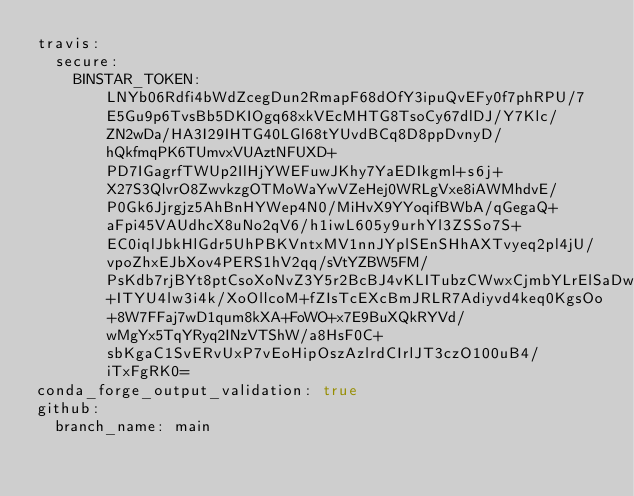<code> <loc_0><loc_0><loc_500><loc_500><_YAML_>travis:
  secure:
    BINSTAR_TOKEN: LNYb06Rdfi4bWdZcegDun2RmapF68dOfY3ipuQvEFy0f7phRPU/7E5Gu9p6TvsBb5DKIOgq68xkVEcMHTG8TsoCy67dlDJ/Y7Klc/ZN2wDa/HA3I29IHTG40LGl68tYUvdBCq8D8ppDvnyD/hQkfmqPK6TUmvxVUAztNFUXD+PD7IGagrfTWUp2IlHjYWEFuwJKhy7YaEDIkgml+s6j+X27S3QlvrO8ZwvkzgOTMoWaYwVZeHej0WRLgVxe8iAWMhdvE/P0Gk6Jjrgjz5AhBnHYWep4N0/MiHvX9YYoqifBWbA/qGegaQ+aFpi45VAUdhcX8uNo2qV6/h1iwL605y9urhYl3ZSSo7S+EC0iqlJbkHlGdr5UhPBKVntxMV1nnJYplSEnSHhAXTvyeq2pl4jU/vpoZhxEJbXov4PERS1hV2qq/sVtYZBW5FM/PsKdb7rjBYt8ptCsoXoNvZ3Y5r2BcBJ4vKLITubzCWwxCjmbYLrElSaDwvo392+ITYU4lw3i4k/XoOllcoM+fZIsTcEXcBmJRLR7Adiyvd4keq0KgsOo+8W7FFaj7wD1qum8kXA+FoWO+x7E9BuXQkRYVd/wMgYx5TqYRyq2INzVTShW/a8HsF0C+sbKgaC1SvERvUxP7vEoHipOszAzlrdCIrlJT3czO100uB4/iTxFgRK0=
conda_forge_output_validation: true
github:
  branch_name: main</code> 